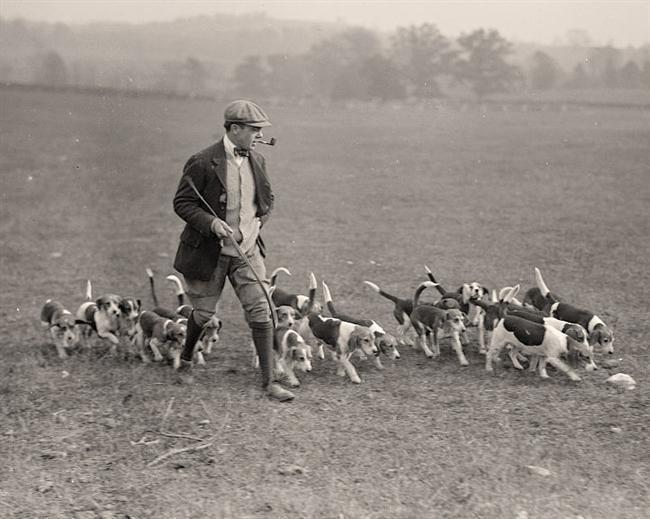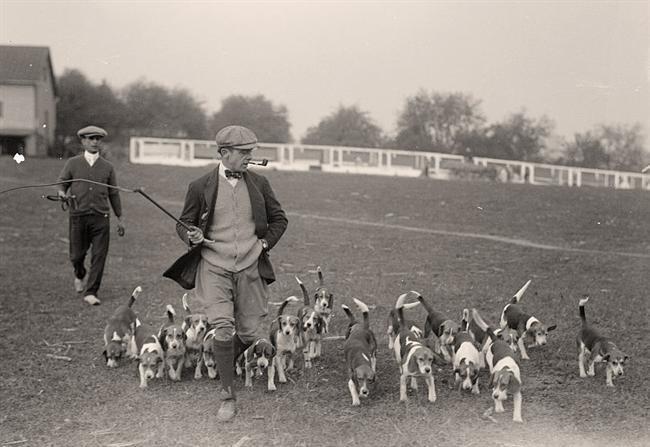The first image is the image on the left, the second image is the image on the right. Analyze the images presented: Is the assertion "Each image shows a pack of dogs near a man in a blazer and cap holding a whip stick." valid? Answer yes or no. Yes. The first image is the image on the left, the second image is the image on the right. For the images displayed, is the sentence "A white fence is visible behind a group of dogs." factually correct? Answer yes or no. Yes. 